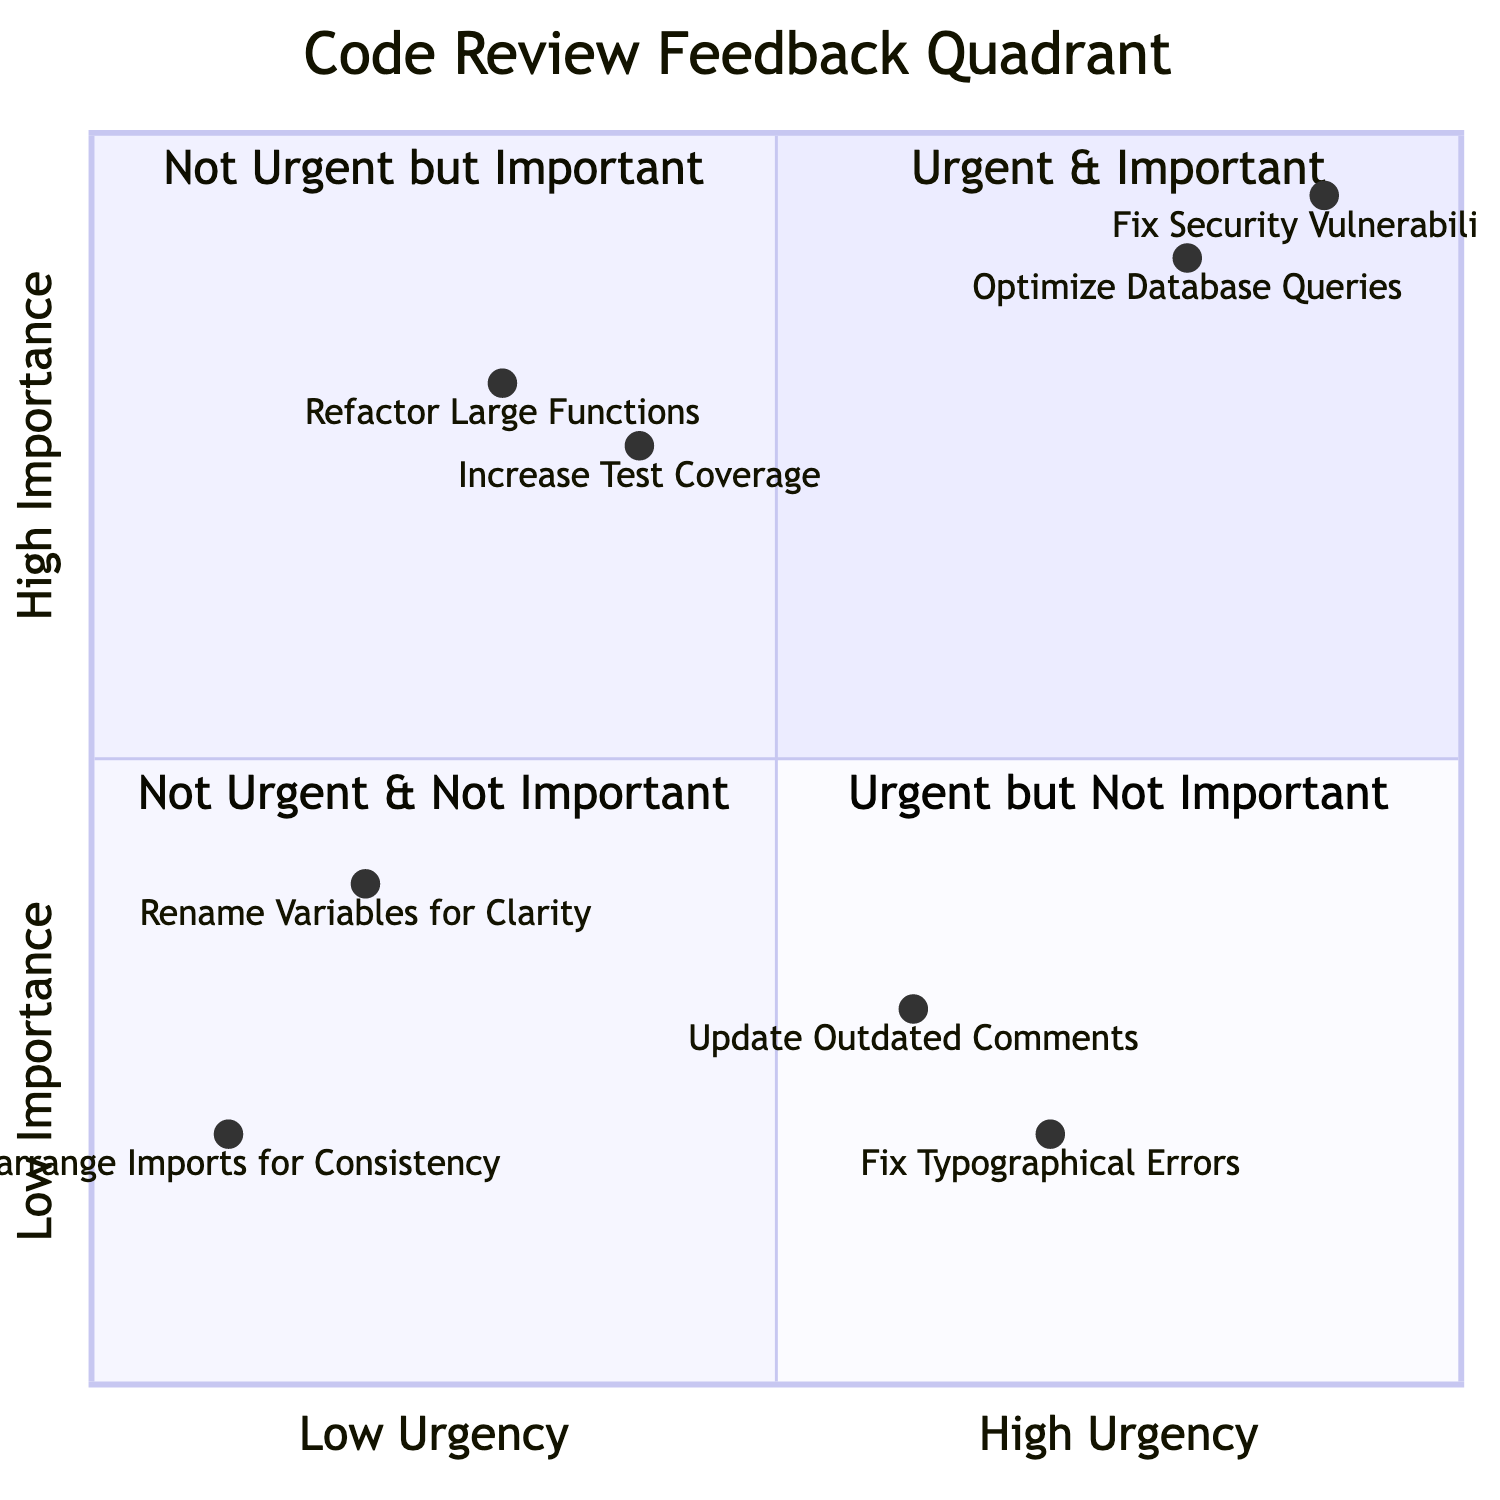What are the two feedback items in the Urgent and Important quadrant? The Urgent and Important quadrant contains two feedback items: "Optimize Database Queries" and "Fix Security Vulnerabilities."
Answer: Optimize Database Queries, Fix Security Vulnerabilities How many feedback items are in the Not Urgent but Important quadrant? There are two feedback items present in the Not Urgent but Important quadrant: "Refactor Large Functions" and "Increase Test Coverage."
Answer: 2 Which feedback item has the highest urgency and importance? By examining the coordinates, "Fix Security Vulnerabilities" at [0.9, 0.95] has the highest urgency and importance in the chart.
Answer: Fix Security Vulnerabilities Is there any feedback that is both urgent and not important? The quadrant shows two feedback items: "Fix Typographical Errors" and "Update Outdated Comments," which are categorized as urgent but not important.
Answer: Yes What is the importance value of "Refactor Large Functions"? The importance value for "Refactor Large Functions" is 0.8 according to its position on the chart.
Answer: 0.8 How does "Rename Variables for Clarity" rank in urgency compared to others? "Rename Variables for Clarity" has a low urgency score of 0.2, making it one of the least urgent items on the chart.
Answer: 0.2 What feedback item appears in the Not Urgent and Not Important quadrant? The Not Urgent and Not Important quadrant includes "Rename Variables for Clarity" and "Rearrange Imports for Consistency."
Answer: Rename Variables for Clarity, Rearrange Imports for Consistency Which feedback in the Urgent but Not Important quadrant has the highest urgency? "Fix Typographical Errors" has a higher urgency score of 0.7 compared to "Update Outdated Comments," which is 0.6.
Answer: Fix Typographical Errors 